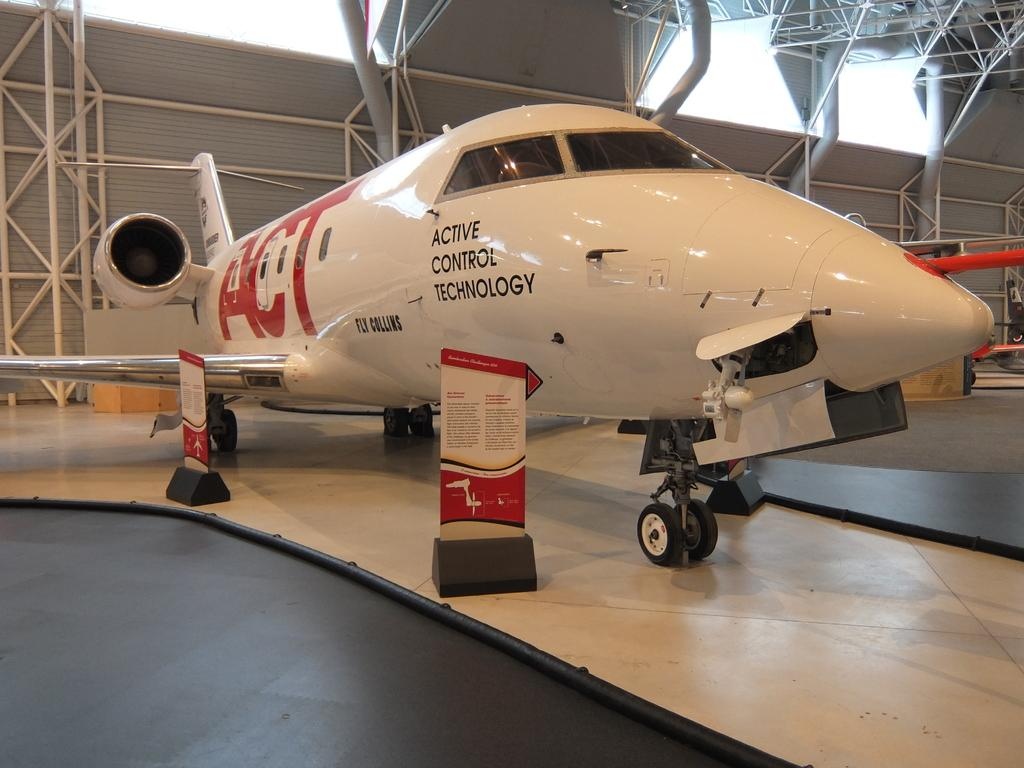Provide a one-sentence caption for the provided image. An active control technology plane sits inside a building. 